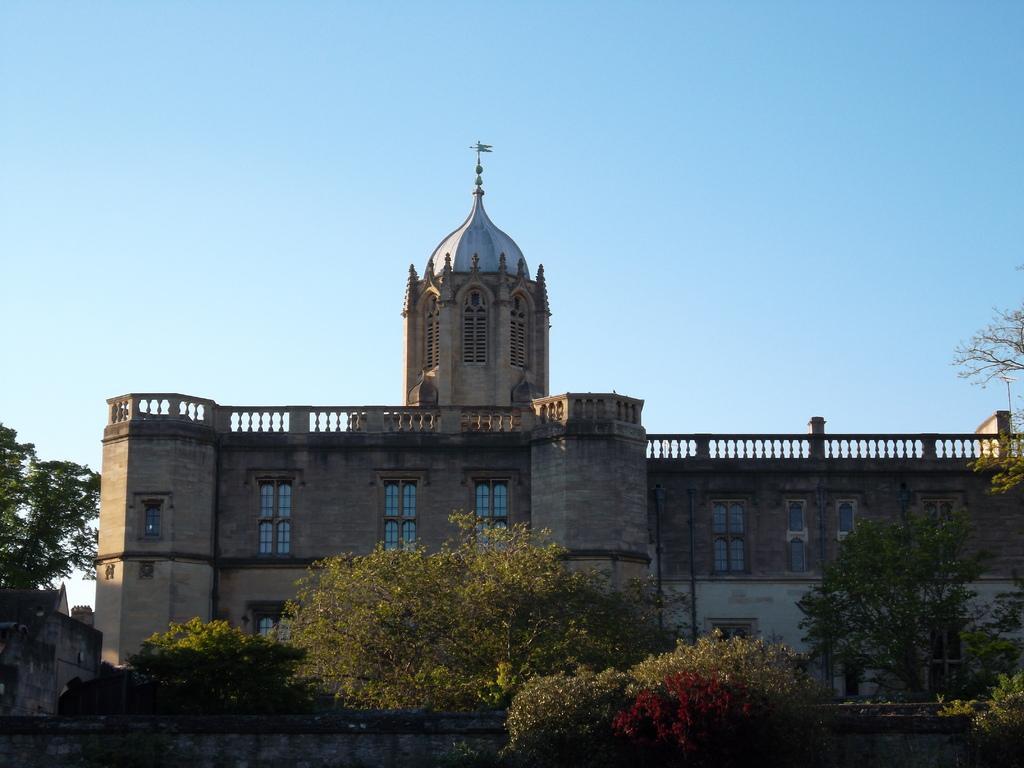Can you describe this image briefly? In this image, we can see buildings and trees. At the top, there is sky. 